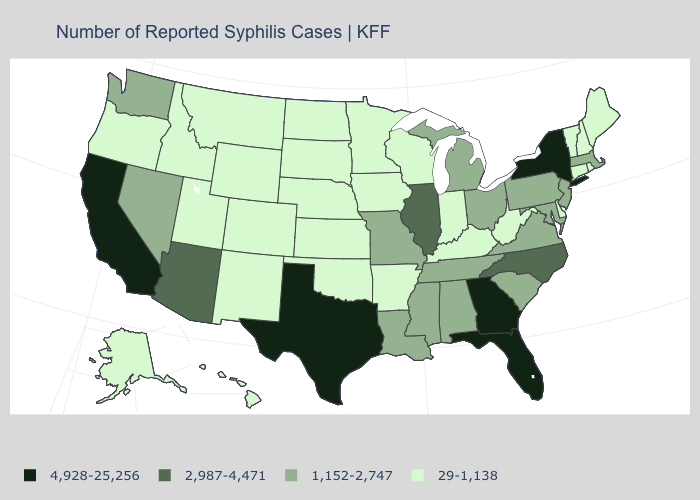Name the states that have a value in the range 1,152-2,747?
Keep it brief. Alabama, Louisiana, Maryland, Massachusetts, Michigan, Mississippi, Missouri, Nevada, New Jersey, Ohio, Pennsylvania, South Carolina, Tennessee, Virginia, Washington. What is the value of Rhode Island?
Be succinct. 29-1,138. Does Indiana have the lowest value in the MidWest?
Give a very brief answer. Yes. What is the value of Louisiana?
Short answer required. 1,152-2,747. Is the legend a continuous bar?
Keep it brief. No. Which states have the lowest value in the USA?
Write a very short answer. Alaska, Arkansas, Colorado, Connecticut, Delaware, Hawaii, Idaho, Indiana, Iowa, Kansas, Kentucky, Maine, Minnesota, Montana, Nebraska, New Hampshire, New Mexico, North Dakota, Oklahoma, Oregon, Rhode Island, South Dakota, Utah, Vermont, West Virginia, Wisconsin, Wyoming. Among the states that border Idaho , does Nevada have the highest value?
Answer briefly. Yes. Does Arizona have a lower value than Wisconsin?
Keep it brief. No. Does North Carolina have the same value as New Mexico?
Write a very short answer. No. Does the first symbol in the legend represent the smallest category?
Short answer required. No. What is the highest value in the USA?
Give a very brief answer. 4,928-25,256. Among the states that border New York , which have the lowest value?
Answer briefly. Connecticut, Vermont. What is the value of New Jersey?
Write a very short answer. 1,152-2,747. 